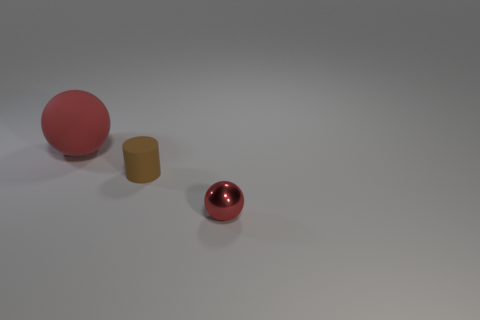How many objects are either large red rubber balls or rubber objects behind the small brown object?
Your answer should be compact. 1. There is a big object that is made of the same material as the tiny cylinder; what is its color?
Give a very brief answer. Red. How many cylinders have the same material as the big ball?
Provide a succinct answer. 1. How many big cyan rubber cubes are there?
Your response must be concise. 0. Does the object behind the brown matte cylinder have the same color as the small thing that is in front of the tiny brown object?
Make the answer very short. Yes. What number of red objects are left of the red metal sphere?
Offer a terse response. 1. What material is the object that is the same color as the tiny ball?
Provide a short and direct response. Rubber. Are there any big cyan matte things that have the same shape as the brown matte object?
Your answer should be compact. No. Does the red thing left of the red shiny sphere have the same material as the sphere to the right of the small cylinder?
Offer a very short reply. No. There is a matte thing to the right of the big red matte sphere that is behind the matte object on the right side of the big red thing; what is its size?
Make the answer very short. Small. 